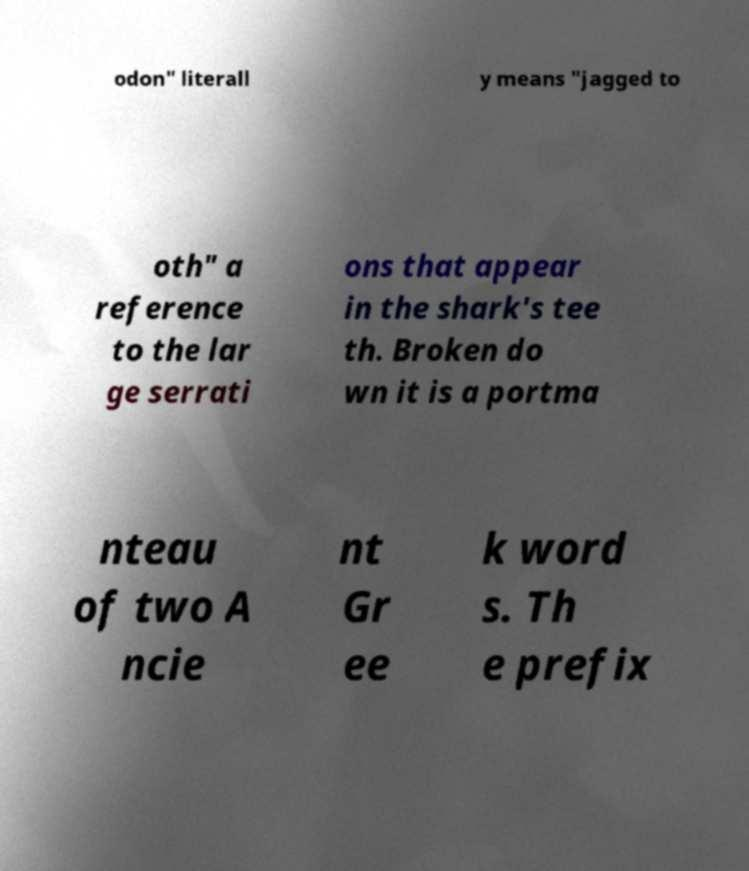Could you assist in decoding the text presented in this image and type it out clearly? odon" literall y means "jagged to oth" a reference to the lar ge serrati ons that appear in the shark's tee th. Broken do wn it is a portma nteau of two A ncie nt Gr ee k word s. Th e prefix 